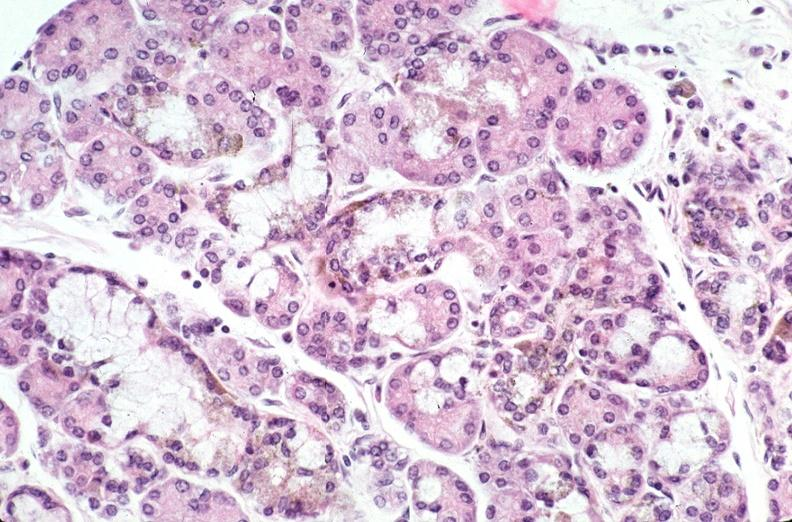does this image show pancreas, hemochromatosis?
Answer the question using a single word or phrase. Yes 